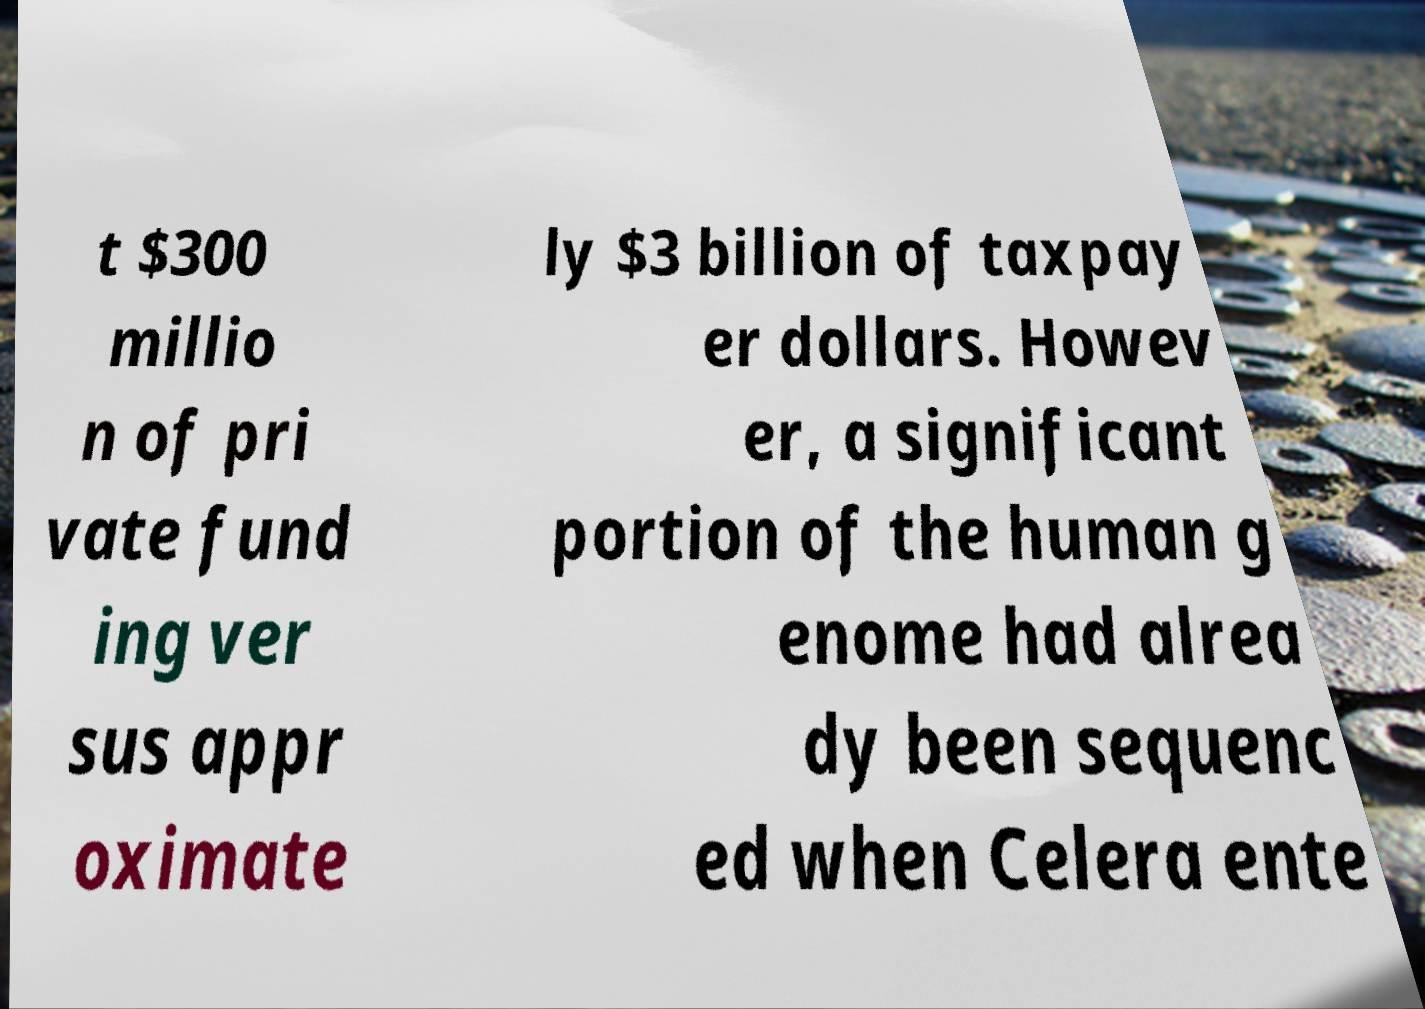Please identify and transcribe the text found in this image. t $300 millio n of pri vate fund ing ver sus appr oximate ly $3 billion of taxpay er dollars. Howev er, a significant portion of the human g enome had alrea dy been sequenc ed when Celera ente 